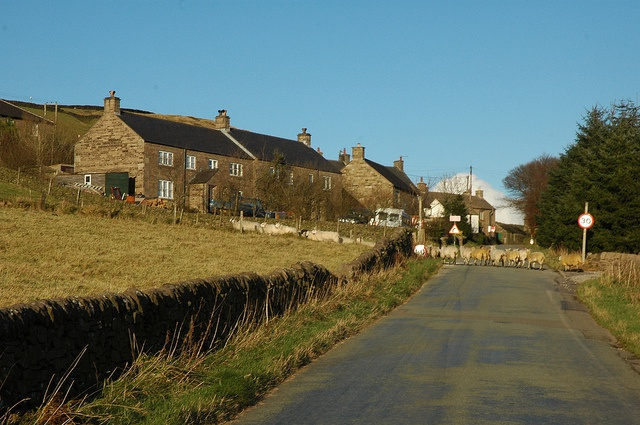Describe the objects in this image and their specific colors. I can see sheep in gray, tan, and olive tones, bus in gray, olive, and tan tones, sheep in gray, tan, and olive tones, sheep in gray, olive, and tan tones, and sheep in gray, tan, and olive tones in this image. 